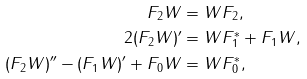Convert formula to latex. <formula><loc_0><loc_0><loc_500><loc_500>F _ { 2 } W & = W F _ { 2 } , \\ 2 ( F _ { 2 } W ) ^ { \prime } & = W F _ { 1 } ^ { * } + F _ { 1 } W , \\ ( F _ { 2 } W ) ^ { \prime \prime } - ( F _ { 1 } W ) ^ { \prime } + F _ { 0 } W & = W F _ { 0 } ^ { * } ,</formula> 